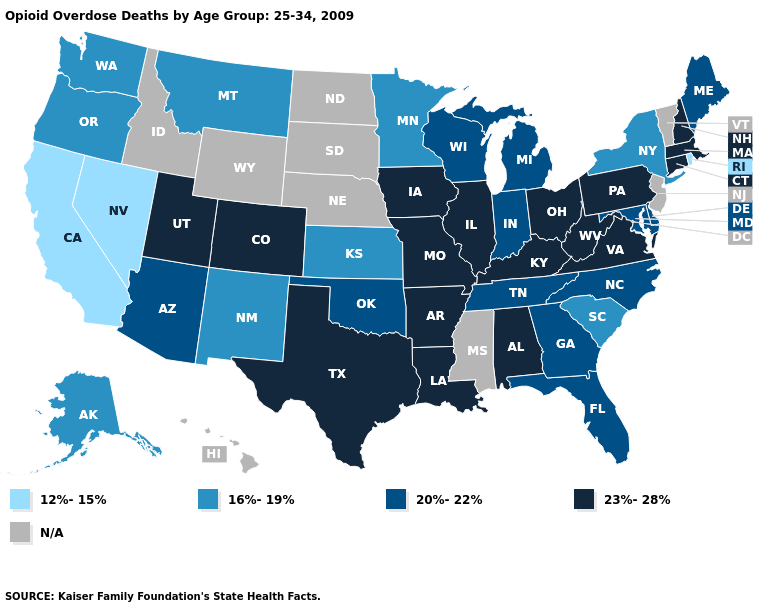What is the value of Pennsylvania?
Keep it brief. 23%-28%. Which states have the highest value in the USA?
Concise answer only. Alabama, Arkansas, Colorado, Connecticut, Illinois, Iowa, Kentucky, Louisiana, Massachusetts, Missouri, New Hampshire, Ohio, Pennsylvania, Texas, Utah, Virginia, West Virginia. What is the value of Maryland?
Keep it brief. 20%-22%. Among the states that border Wisconsin , does Michigan have the lowest value?
Give a very brief answer. No. Name the states that have a value in the range 16%-19%?
Short answer required. Alaska, Kansas, Minnesota, Montana, New Mexico, New York, Oregon, South Carolina, Washington. Among the states that border Colorado , which have the lowest value?
Write a very short answer. Kansas, New Mexico. Does the map have missing data?
Short answer required. Yes. Which states have the lowest value in the Northeast?
Concise answer only. Rhode Island. What is the value of Ohio?
Concise answer only. 23%-28%. Which states have the highest value in the USA?
Write a very short answer. Alabama, Arkansas, Colorado, Connecticut, Illinois, Iowa, Kentucky, Louisiana, Massachusetts, Missouri, New Hampshire, Ohio, Pennsylvania, Texas, Utah, Virginia, West Virginia. Does Missouri have the highest value in the USA?
Quick response, please. Yes. Does Maryland have the lowest value in the USA?
Write a very short answer. No. Does Louisiana have the highest value in the South?
Answer briefly. Yes. What is the highest value in the MidWest ?
Be succinct. 23%-28%. Name the states that have a value in the range N/A?
Keep it brief. Hawaii, Idaho, Mississippi, Nebraska, New Jersey, North Dakota, South Dakota, Vermont, Wyoming. 